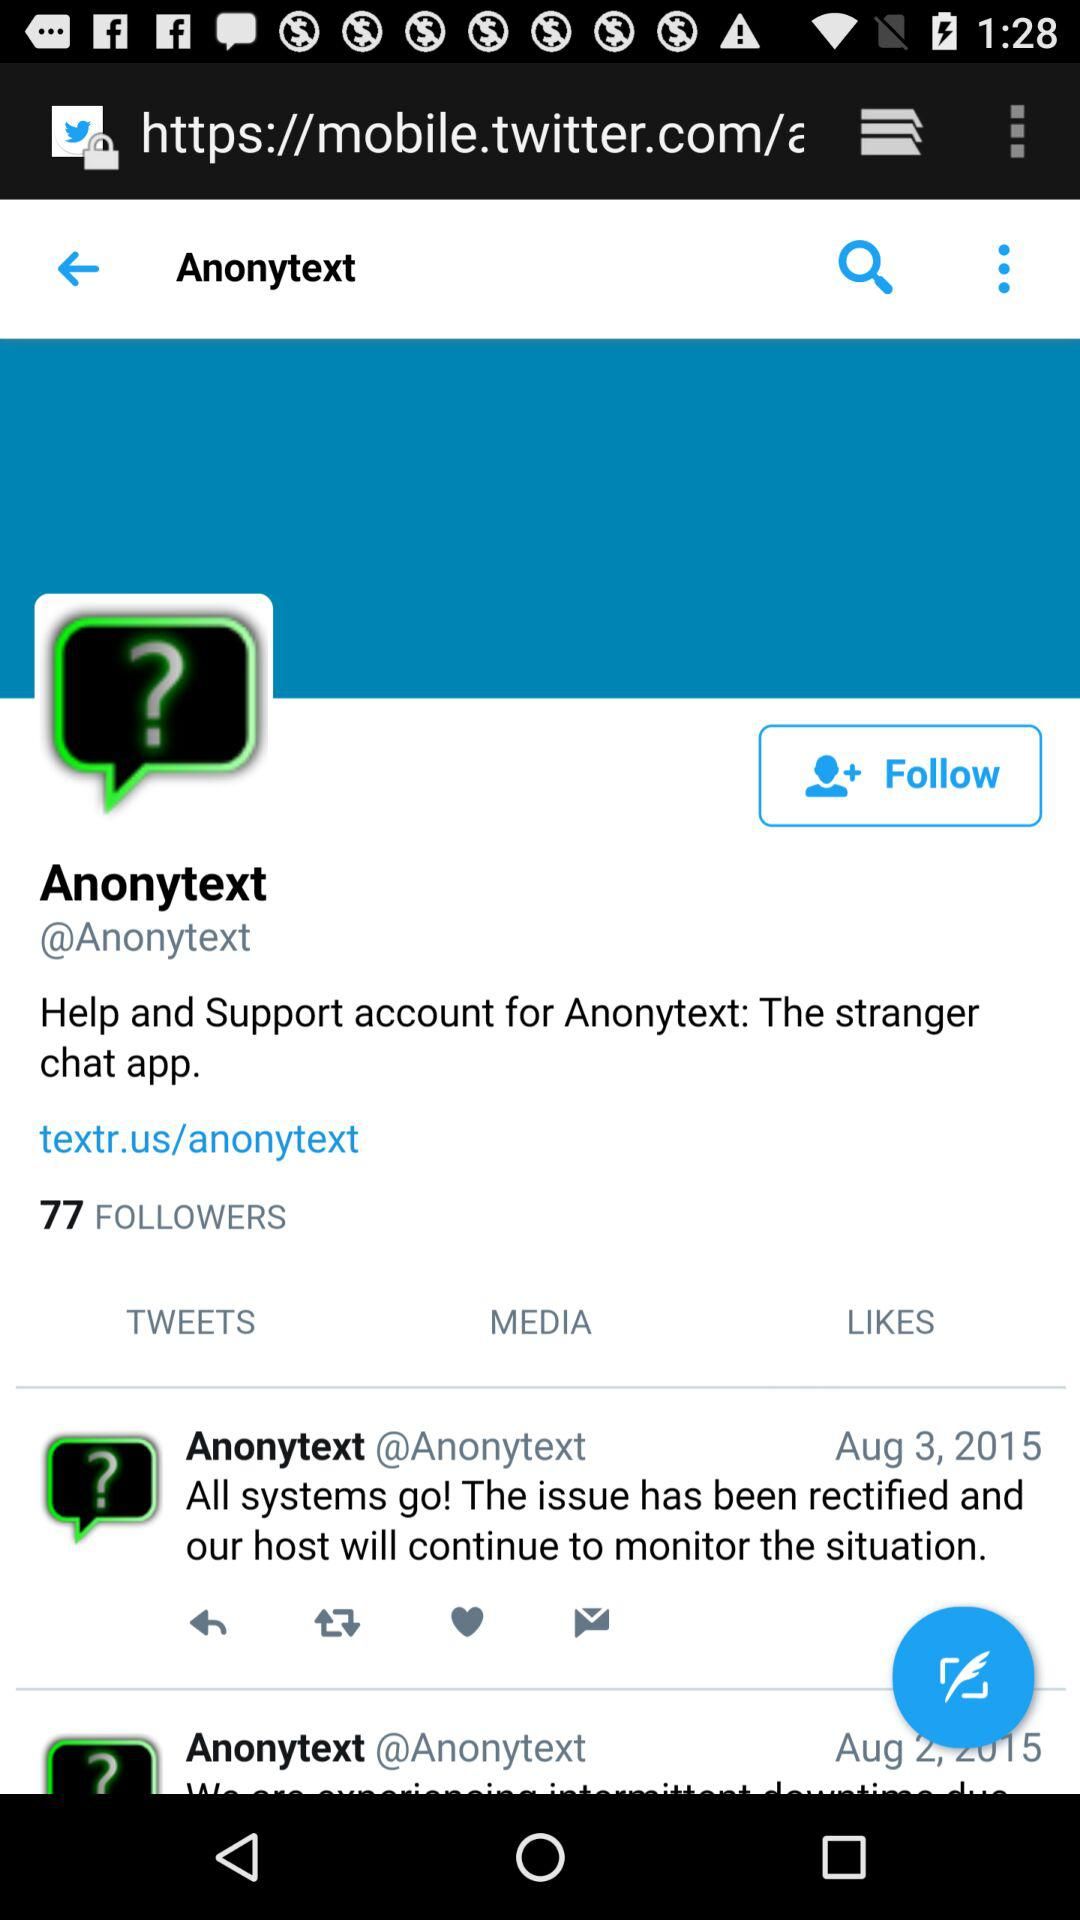On which date "Anonytext" updated the post? The post was updated on August 3, 2015 and August 2, 2015. 